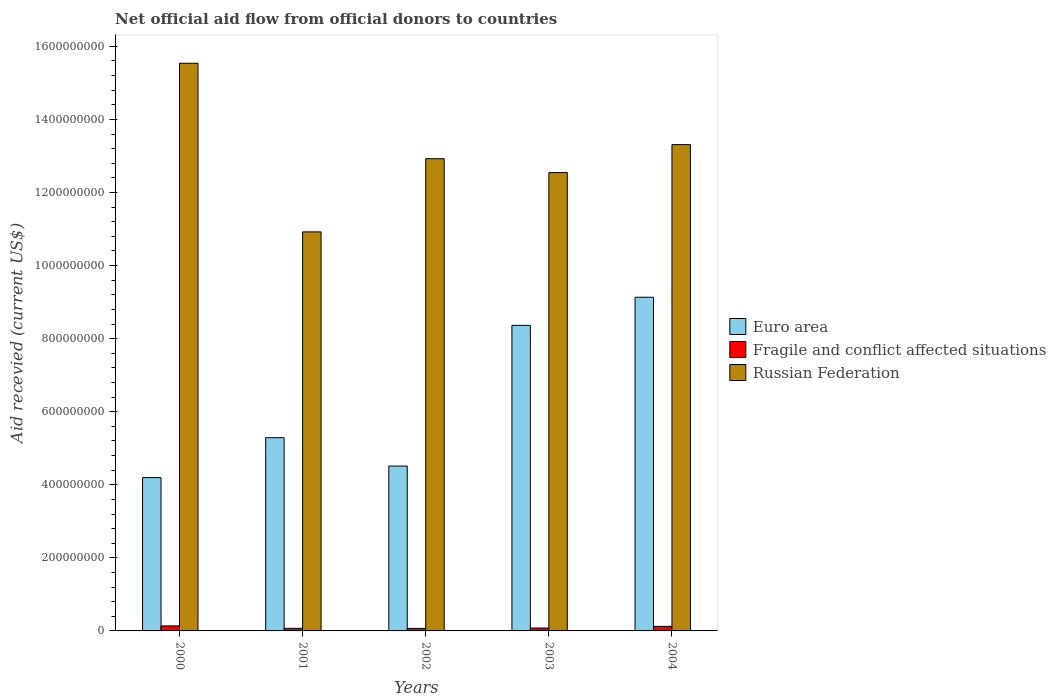How many groups of bars are there?
Give a very brief answer. 5. Are the number of bars per tick equal to the number of legend labels?
Give a very brief answer. Yes. Are the number of bars on each tick of the X-axis equal?
Provide a short and direct response. Yes. In how many cases, is the number of bars for a given year not equal to the number of legend labels?
Offer a terse response. 0. What is the total aid received in Fragile and conflict affected situations in 2002?
Provide a short and direct response. 6.88e+06. Across all years, what is the maximum total aid received in Fragile and conflict affected situations?
Your answer should be compact. 1.38e+07. Across all years, what is the minimum total aid received in Russian Federation?
Your answer should be compact. 1.09e+09. What is the total total aid received in Fragile and conflict affected situations in the graph?
Ensure brevity in your answer.  4.82e+07. What is the difference between the total aid received in Russian Federation in 2002 and that in 2003?
Ensure brevity in your answer.  3.80e+07. What is the difference between the total aid received in Russian Federation in 2003 and the total aid received in Fragile and conflict affected situations in 2004?
Make the answer very short. 1.24e+09. What is the average total aid received in Euro area per year?
Provide a short and direct response. 6.30e+08. In the year 2004, what is the difference between the total aid received in Russian Federation and total aid received in Fragile and conflict affected situations?
Keep it short and to the point. 1.32e+09. In how many years, is the total aid received in Russian Federation greater than 480000000 US$?
Ensure brevity in your answer.  5. What is the ratio of the total aid received in Euro area in 2001 to that in 2003?
Give a very brief answer. 0.63. Is the difference between the total aid received in Russian Federation in 2002 and 2003 greater than the difference between the total aid received in Fragile and conflict affected situations in 2002 and 2003?
Keep it short and to the point. Yes. What is the difference between the highest and the second highest total aid received in Russian Federation?
Provide a short and direct response. 2.23e+08. What is the difference between the highest and the lowest total aid received in Euro area?
Provide a succinct answer. 4.94e+08. In how many years, is the total aid received in Russian Federation greater than the average total aid received in Russian Federation taken over all years?
Provide a short and direct response. 2. What does the 2nd bar from the left in 2000 represents?
Your answer should be very brief. Fragile and conflict affected situations. What does the 3rd bar from the right in 2002 represents?
Give a very brief answer. Euro area. Is it the case that in every year, the sum of the total aid received in Euro area and total aid received in Russian Federation is greater than the total aid received in Fragile and conflict affected situations?
Give a very brief answer. Yes. How many years are there in the graph?
Ensure brevity in your answer.  5. Are the values on the major ticks of Y-axis written in scientific E-notation?
Provide a short and direct response. No. Where does the legend appear in the graph?
Provide a short and direct response. Center right. What is the title of the graph?
Provide a succinct answer. Net official aid flow from official donors to countries. Does "New Caledonia" appear as one of the legend labels in the graph?
Your answer should be very brief. No. What is the label or title of the Y-axis?
Your response must be concise. Aid recevied (current US$). What is the Aid recevied (current US$) in Euro area in 2000?
Your answer should be compact. 4.20e+08. What is the Aid recevied (current US$) of Fragile and conflict affected situations in 2000?
Keep it short and to the point. 1.38e+07. What is the Aid recevied (current US$) of Russian Federation in 2000?
Offer a very short reply. 1.55e+09. What is the Aid recevied (current US$) of Euro area in 2001?
Offer a terse response. 5.29e+08. What is the Aid recevied (current US$) in Fragile and conflict affected situations in 2001?
Your response must be concise. 7.14e+06. What is the Aid recevied (current US$) of Russian Federation in 2001?
Your response must be concise. 1.09e+09. What is the Aid recevied (current US$) in Euro area in 2002?
Keep it short and to the point. 4.51e+08. What is the Aid recevied (current US$) of Fragile and conflict affected situations in 2002?
Your answer should be very brief. 6.88e+06. What is the Aid recevied (current US$) in Russian Federation in 2002?
Your answer should be very brief. 1.29e+09. What is the Aid recevied (current US$) in Euro area in 2003?
Give a very brief answer. 8.36e+08. What is the Aid recevied (current US$) of Fragile and conflict affected situations in 2003?
Offer a terse response. 7.95e+06. What is the Aid recevied (current US$) in Russian Federation in 2003?
Give a very brief answer. 1.25e+09. What is the Aid recevied (current US$) of Euro area in 2004?
Your response must be concise. 9.13e+08. What is the Aid recevied (current US$) of Fragile and conflict affected situations in 2004?
Offer a very short reply. 1.24e+07. What is the Aid recevied (current US$) in Russian Federation in 2004?
Keep it short and to the point. 1.33e+09. Across all years, what is the maximum Aid recevied (current US$) in Euro area?
Ensure brevity in your answer.  9.13e+08. Across all years, what is the maximum Aid recevied (current US$) of Fragile and conflict affected situations?
Provide a short and direct response. 1.38e+07. Across all years, what is the maximum Aid recevied (current US$) in Russian Federation?
Give a very brief answer. 1.55e+09. Across all years, what is the minimum Aid recevied (current US$) in Euro area?
Offer a very short reply. 4.20e+08. Across all years, what is the minimum Aid recevied (current US$) in Fragile and conflict affected situations?
Ensure brevity in your answer.  6.88e+06. Across all years, what is the minimum Aid recevied (current US$) of Russian Federation?
Your answer should be compact. 1.09e+09. What is the total Aid recevied (current US$) in Euro area in the graph?
Make the answer very short. 3.15e+09. What is the total Aid recevied (current US$) in Fragile and conflict affected situations in the graph?
Keep it short and to the point. 4.82e+07. What is the total Aid recevied (current US$) of Russian Federation in the graph?
Keep it short and to the point. 6.52e+09. What is the difference between the Aid recevied (current US$) of Euro area in 2000 and that in 2001?
Provide a short and direct response. -1.09e+08. What is the difference between the Aid recevied (current US$) in Fragile and conflict affected situations in 2000 and that in 2001?
Your answer should be compact. 6.61e+06. What is the difference between the Aid recevied (current US$) of Russian Federation in 2000 and that in 2001?
Provide a short and direct response. 4.62e+08. What is the difference between the Aid recevied (current US$) in Euro area in 2000 and that in 2002?
Offer a terse response. -3.16e+07. What is the difference between the Aid recevied (current US$) of Fragile and conflict affected situations in 2000 and that in 2002?
Your answer should be very brief. 6.87e+06. What is the difference between the Aid recevied (current US$) in Russian Federation in 2000 and that in 2002?
Ensure brevity in your answer.  2.61e+08. What is the difference between the Aid recevied (current US$) in Euro area in 2000 and that in 2003?
Provide a succinct answer. -4.17e+08. What is the difference between the Aid recevied (current US$) of Fragile and conflict affected situations in 2000 and that in 2003?
Your answer should be very brief. 5.80e+06. What is the difference between the Aid recevied (current US$) in Russian Federation in 2000 and that in 2003?
Your answer should be very brief. 2.99e+08. What is the difference between the Aid recevied (current US$) of Euro area in 2000 and that in 2004?
Give a very brief answer. -4.94e+08. What is the difference between the Aid recevied (current US$) in Fragile and conflict affected situations in 2000 and that in 2004?
Your answer should be compact. 1.32e+06. What is the difference between the Aid recevied (current US$) in Russian Federation in 2000 and that in 2004?
Your response must be concise. 2.23e+08. What is the difference between the Aid recevied (current US$) in Euro area in 2001 and that in 2002?
Your answer should be compact. 7.77e+07. What is the difference between the Aid recevied (current US$) in Russian Federation in 2001 and that in 2002?
Your response must be concise. -2.00e+08. What is the difference between the Aid recevied (current US$) of Euro area in 2001 and that in 2003?
Offer a very short reply. -3.08e+08. What is the difference between the Aid recevied (current US$) in Fragile and conflict affected situations in 2001 and that in 2003?
Your answer should be compact. -8.10e+05. What is the difference between the Aid recevied (current US$) of Russian Federation in 2001 and that in 2003?
Your answer should be compact. -1.62e+08. What is the difference between the Aid recevied (current US$) in Euro area in 2001 and that in 2004?
Provide a succinct answer. -3.84e+08. What is the difference between the Aid recevied (current US$) in Fragile and conflict affected situations in 2001 and that in 2004?
Provide a succinct answer. -5.29e+06. What is the difference between the Aid recevied (current US$) of Russian Federation in 2001 and that in 2004?
Your answer should be very brief. -2.39e+08. What is the difference between the Aid recevied (current US$) of Euro area in 2002 and that in 2003?
Offer a very short reply. -3.85e+08. What is the difference between the Aid recevied (current US$) of Fragile and conflict affected situations in 2002 and that in 2003?
Offer a very short reply. -1.07e+06. What is the difference between the Aid recevied (current US$) of Russian Federation in 2002 and that in 2003?
Keep it short and to the point. 3.80e+07. What is the difference between the Aid recevied (current US$) in Euro area in 2002 and that in 2004?
Ensure brevity in your answer.  -4.62e+08. What is the difference between the Aid recevied (current US$) in Fragile and conflict affected situations in 2002 and that in 2004?
Your answer should be compact. -5.55e+06. What is the difference between the Aid recevied (current US$) of Russian Federation in 2002 and that in 2004?
Provide a succinct answer. -3.86e+07. What is the difference between the Aid recevied (current US$) of Euro area in 2003 and that in 2004?
Your answer should be very brief. -7.69e+07. What is the difference between the Aid recevied (current US$) of Fragile and conflict affected situations in 2003 and that in 2004?
Keep it short and to the point. -4.48e+06. What is the difference between the Aid recevied (current US$) of Russian Federation in 2003 and that in 2004?
Make the answer very short. -7.66e+07. What is the difference between the Aid recevied (current US$) in Euro area in 2000 and the Aid recevied (current US$) in Fragile and conflict affected situations in 2001?
Your answer should be compact. 4.12e+08. What is the difference between the Aid recevied (current US$) in Euro area in 2000 and the Aid recevied (current US$) in Russian Federation in 2001?
Offer a very short reply. -6.73e+08. What is the difference between the Aid recevied (current US$) of Fragile and conflict affected situations in 2000 and the Aid recevied (current US$) of Russian Federation in 2001?
Offer a very short reply. -1.08e+09. What is the difference between the Aid recevied (current US$) of Euro area in 2000 and the Aid recevied (current US$) of Fragile and conflict affected situations in 2002?
Give a very brief answer. 4.13e+08. What is the difference between the Aid recevied (current US$) in Euro area in 2000 and the Aid recevied (current US$) in Russian Federation in 2002?
Offer a terse response. -8.73e+08. What is the difference between the Aid recevied (current US$) of Fragile and conflict affected situations in 2000 and the Aid recevied (current US$) of Russian Federation in 2002?
Your answer should be compact. -1.28e+09. What is the difference between the Aid recevied (current US$) of Euro area in 2000 and the Aid recevied (current US$) of Fragile and conflict affected situations in 2003?
Your answer should be very brief. 4.12e+08. What is the difference between the Aid recevied (current US$) in Euro area in 2000 and the Aid recevied (current US$) in Russian Federation in 2003?
Give a very brief answer. -8.35e+08. What is the difference between the Aid recevied (current US$) of Fragile and conflict affected situations in 2000 and the Aid recevied (current US$) of Russian Federation in 2003?
Your response must be concise. -1.24e+09. What is the difference between the Aid recevied (current US$) of Euro area in 2000 and the Aid recevied (current US$) of Fragile and conflict affected situations in 2004?
Offer a very short reply. 4.07e+08. What is the difference between the Aid recevied (current US$) of Euro area in 2000 and the Aid recevied (current US$) of Russian Federation in 2004?
Give a very brief answer. -9.11e+08. What is the difference between the Aid recevied (current US$) of Fragile and conflict affected situations in 2000 and the Aid recevied (current US$) of Russian Federation in 2004?
Your response must be concise. -1.32e+09. What is the difference between the Aid recevied (current US$) in Euro area in 2001 and the Aid recevied (current US$) in Fragile and conflict affected situations in 2002?
Make the answer very short. 5.22e+08. What is the difference between the Aid recevied (current US$) in Euro area in 2001 and the Aid recevied (current US$) in Russian Federation in 2002?
Ensure brevity in your answer.  -7.64e+08. What is the difference between the Aid recevied (current US$) of Fragile and conflict affected situations in 2001 and the Aid recevied (current US$) of Russian Federation in 2002?
Give a very brief answer. -1.29e+09. What is the difference between the Aid recevied (current US$) of Euro area in 2001 and the Aid recevied (current US$) of Fragile and conflict affected situations in 2003?
Offer a terse response. 5.21e+08. What is the difference between the Aid recevied (current US$) in Euro area in 2001 and the Aid recevied (current US$) in Russian Federation in 2003?
Make the answer very short. -7.26e+08. What is the difference between the Aid recevied (current US$) in Fragile and conflict affected situations in 2001 and the Aid recevied (current US$) in Russian Federation in 2003?
Your response must be concise. -1.25e+09. What is the difference between the Aid recevied (current US$) in Euro area in 2001 and the Aid recevied (current US$) in Fragile and conflict affected situations in 2004?
Ensure brevity in your answer.  5.16e+08. What is the difference between the Aid recevied (current US$) in Euro area in 2001 and the Aid recevied (current US$) in Russian Federation in 2004?
Provide a succinct answer. -8.02e+08. What is the difference between the Aid recevied (current US$) in Fragile and conflict affected situations in 2001 and the Aid recevied (current US$) in Russian Federation in 2004?
Offer a very short reply. -1.32e+09. What is the difference between the Aid recevied (current US$) of Euro area in 2002 and the Aid recevied (current US$) of Fragile and conflict affected situations in 2003?
Ensure brevity in your answer.  4.43e+08. What is the difference between the Aid recevied (current US$) of Euro area in 2002 and the Aid recevied (current US$) of Russian Federation in 2003?
Give a very brief answer. -8.03e+08. What is the difference between the Aid recevied (current US$) in Fragile and conflict affected situations in 2002 and the Aid recevied (current US$) in Russian Federation in 2003?
Your answer should be very brief. -1.25e+09. What is the difference between the Aid recevied (current US$) of Euro area in 2002 and the Aid recevied (current US$) of Fragile and conflict affected situations in 2004?
Ensure brevity in your answer.  4.39e+08. What is the difference between the Aid recevied (current US$) in Euro area in 2002 and the Aid recevied (current US$) in Russian Federation in 2004?
Make the answer very short. -8.80e+08. What is the difference between the Aid recevied (current US$) of Fragile and conflict affected situations in 2002 and the Aid recevied (current US$) of Russian Federation in 2004?
Make the answer very short. -1.32e+09. What is the difference between the Aid recevied (current US$) of Euro area in 2003 and the Aid recevied (current US$) of Fragile and conflict affected situations in 2004?
Offer a terse response. 8.24e+08. What is the difference between the Aid recevied (current US$) in Euro area in 2003 and the Aid recevied (current US$) in Russian Federation in 2004?
Give a very brief answer. -4.95e+08. What is the difference between the Aid recevied (current US$) of Fragile and conflict affected situations in 2003 and the Aid recevied (current US$) of Russian Federation in 2004?
Keep it short and to the point. -1.32e+09. What is the average Aid recevied (current US$) of Euro area per year?
Your response must be concise. 6.30e+08. What is the average Aid recevied (current US$) of Fragile and conflict affected situations per year?
Keep it short and to the point. 9.63e+06. What is the average Aid recevied (current US$) in Russian Federation per year?
Keep it short and to the point. 1.30e+09. In the year 2000, what is the difference between the Aid recevied (current US$) of Euro area and Aid recevied (current US$) of Fragile and conflict affected situations?
Provide a short and direct response. 4.06e+08. In the year 2000, what is the difference between the Aid recevied (current US$) of Euro area and Aid recevied (current US$) of Russian Federation?
Provide a succinct answer. -1.13e+09. In the year 2000, what is the difference between the Aid recevied (current US$) in Fragile and conflict affected situations and Aid recevied (current US$) in Russian Federation?
Your answer should be very brief. -1.54e+09. In the year 2001, what is the difference between the Aid recevied (current US$) of Euro area and Aid recevied (current US$) of Fragile and conflict affected situations?
Make the answer very short. 5.22e+08. In the year 2001, what is the difference between the Aid recevied (current US$) in Euro area and Aid recevied (current US$) in Russian Federation?
Make the answer very short. -5.63e+08. In the year 2001, what is the difference between the Aid recevied (current US$) in Fragile and conflict affected situations and Aid recevied (current US$) in Russian Federation?
Provide a succinct answer. -1.09e+09. In the year 2002, what is the difference between the Aid recevied (current US$) of Euro area and Aid recevied (current US$) of Fragile and conflict affected situations?
Offer a terse response. 4.44e+08. In the year 2002, what is the difference between the Aid recevied (current US$) of Euro area and Aid recevied (current US$) of Russian Federation?
Keep it short and to the point. -8.41e+08. In the year 2002, what is the difference between the Aid recevied (current US$) of Fragile and conflict affected situations and Aid recevied (current US$) of Russian Federation?
Offer a terse response. -1.29e+09. In the year 2003, what is the difference between the Aid recevied (current US$) in Euro area and Aid recevied (current US$) in Fragile and conflict affected situations?
Ensure brevity in your answer.  8.28e+08. In the year 2003, what is the difference between the Aid recevied (current US$) of Euro area and Aid recevied (current US$) of Russian Federation?
Offer a terse response. -4.18e+08. In the year 2003, what is the difference between the Aid recevied (current US$) in Fragile and conflict affected situations and Aid recevied (current US$) in Russian Federation?
Provide a short and direct response. -1.25e+09. In the year 2004, what is the difference between the Aid recevied (current US$) in Euro area and Aid recevied (current US$) in Fragile and conflict affected situations?
Provide a short and direct response. 9.01e+08. In the year 2004, what is the difference between the Aid recevied (current US$) in Euro area and Aid recevied (current US$) in Russian Federation?
Your response must be concise. -4.18e+08. In the year 2004, what is the difference between the Aid recevied (current US$) in Fragile and conflict affected situations and Aid recevied (current US$) in Russian Federation?
Make the answer very short. -1.32e+09. What is the ratio of the Aid recevied (current US$) in Euro area in 2000 to that in 2001?
Give a very brief answer. 0.79. What is the ratio of the Aid recevied (current US$) of Fragile and conflict affected situations in 2000 to that in 2001?
Keep it short and to the point. 1.93. What is the ratio of the Aid recevied (current US$) of Russian Federation in 2000 to that in 2001?
Provide a short and direct response. 1.42. What is the ratio of the Aid recevied (current US$) in Euro area in 2000 to that in 2002?
Ensure brevity in your answer.  0.93. What is the ratio of the Aid recevied (current US$) of Fragile and conflict affected situations in 2000 to that in 2002?
Your answer should be very brief. 2. What is the ratio of the Aid recevied (current US$) in Russian Federation in 2000 to that in 2002?
Your answer should be compact. 1.2. What is the ratio of the Aid recevied (current US$) in Euro area in 2000 to that in 2003?
Keep it short and to the point. 0.5. What is the ratio of the Aid recevied (current US$) in Fragile and conflict affected situations in 2000 to that in 2003?
Your response must be concise. 1.73. What is the ratio of the Aid recevied (current US$) in Russian Federation in 2000 to that in 2003?
Your answer should be compact. 1.24. What is the ratio of the Aid recevied (current US$) in Euro area in 2000 to that in 2004?
Provide a short and direct response. 0.46. What is the ratio of the Aid recevied (current US$) of Fragile and conflict affected situations in 2000 to that in 2004?
Make the answer very short. 1.11. What is the ratio of the Aid recevied (current US$) of Russian Federation in 2000 to that in 2004?
Keep it short and to the point. 1.17. What is the ratio of the Aid recevied (current US$) of Euro area in 2001 to that in 2002?
Give a very brief answer. 1.17. What is the ratio of the Aid recevied (current US$) of Fragile and conflict affected situations in 2001 to that in 2002?
Provide a short and direct response. 1.04. What is the ratio of the Aid recevied (current US$) in Russian Federation in 2001 to that in 2002?
Offer a terse response. 0.84. What is the ratio of the Aid recevied (current US$) in Euro area in 2001 to that in 2003?
Your response must be concise. 0.63. What is the ratio of the Aid recevied (current US$) of Fragile and conflict affected situations in 2001 to that in 2003?
Make the answer very short. 0.9. What is the ratio of the Aid recevied (current US$) in Russian Federation in 2001 to that in 2003?
Provide a succinct answer. 0.87. What is the ratio of the Aid recevied (current US$) of Euro area in 2001 to that in 2004?
Provide a succinct answer. 0.58. What is the ratio of the Aid recevied (current US$) of Fragile and conflict affected situations in 2001 to that in 2004?
Your answer should be compact. 0.57. What is the ratio of the Aid recevied (current US$) in Russian Federation in 2001 to that in 2004?
Your answer should be very brief. 0.82. What is the ratio of the Aid recevied (current US$) of Euro area in 2002 to that in 2003?
Ensure brevity in your answer.  0.54. What is the ratio of the Aid recevied (current US$) in Fragile and conflict affected situations in 2002 to that in 2003?
Ensure brevity in your answer.  0.87. What is the ratio of the Aid recevied (current US$) in Russian Federation in 2002 to that in 2003?
Offer a terse response. 1.03. What is the ratio of the Aid recevied (current US$) in Euro area in 2002 to that in 2004?
Give a very brief answer. 0.49. What is the ratio of the Aid recevied (current US$) of Fragile and conflict affected situations in 2002 to that in 2004?
Offer a terse response. 0.55. What is the ratio of the Aid recevied (current US$) in Euro area in 2003 to that in 2004?
Ensure brevity in your answer.  0.92. What is the ratio of the Aid recevied (current US$) of Fragile and conflict affected situations in 2003 to that in 2004?
Give a very brief answer. 0.64. What is the ratio of the Aid recevied (current US$) in Russian Federation in 2003 to that in 2004?
Provide a short and direct response. 0.94. What is the difference between the highest and the second highest Aid recevied (current US$) of Euro area?
Offer a terse response. 7.69e+07. What is the difference between the highest and the second highest Aid recevied (current US$) in Fragile and conflict affected situations?
Keep it short and to the point. 1.32e+06. What is the difference between the highest and the second highest Aid recevied (current US$) in Russian Federation?
Give a very brief answer. 2.23e+08. What is the difference between the highest and the lowest Aid recevied (current US$) in Euro area?
Your response must be concise. 4.94e+08. What is the difference between the highest and the lowest Aid recevied (current US$) in Fragile and conflict affected situations?
Provide a succinct answer. 6.87e+06. What is the difference between the highest and the lowest Aid recevied (current US$) of Russian Federation?
Your response must be concise. 4.62e+08. 